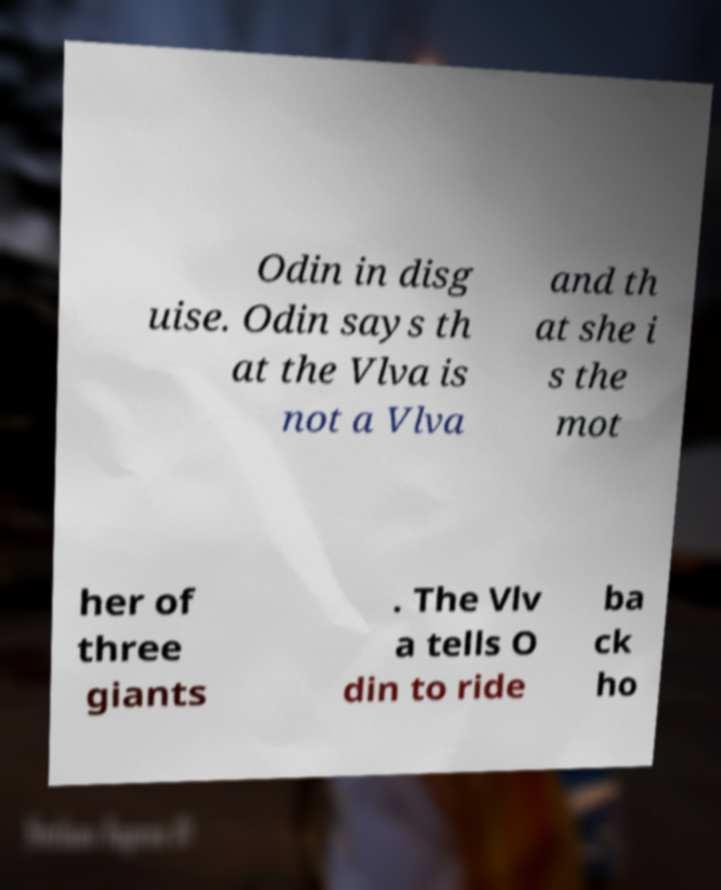Can you accurately transcribe the text from the provided image for me? Odin in disg uise. Odin says th at the Vlva is not a Vlva and th at she i s the mot her of three giants . The Vlv a tells O din to ride ba ck ho 